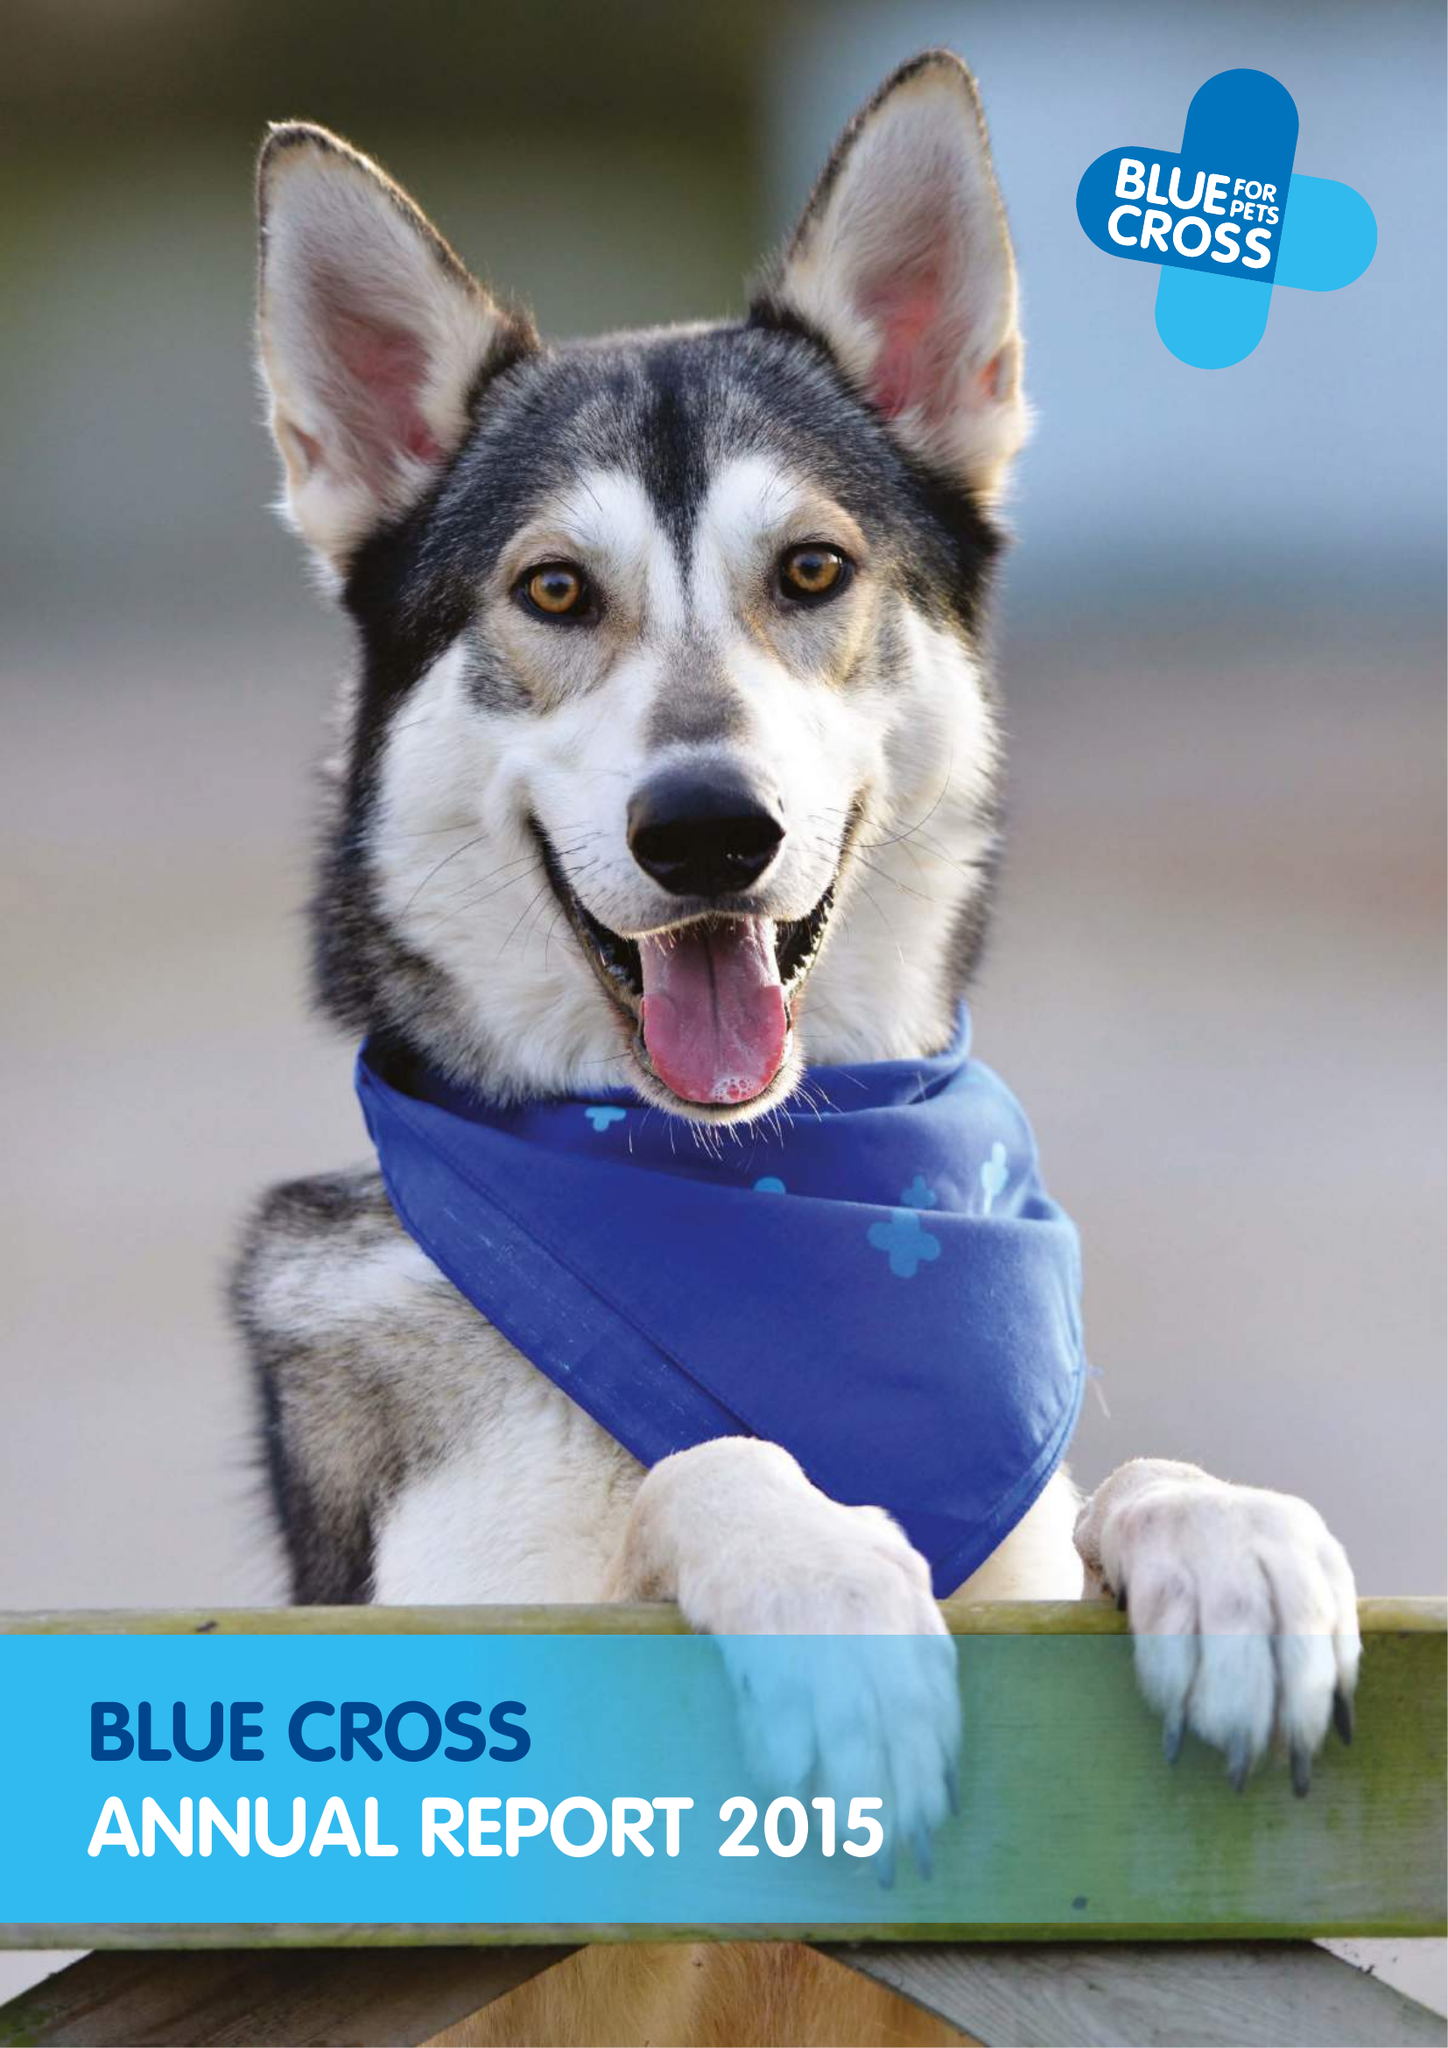What is the value for the address__street_line?
Answer the question using a single word or phrase. SHILTON ROAD 